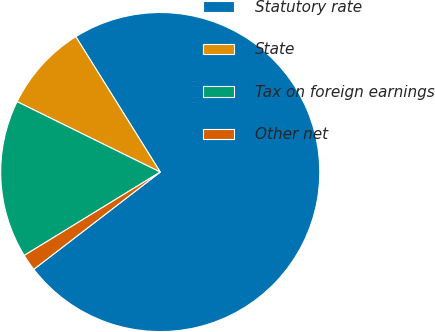Convert chart to OTSL. <chart><loc_0><loc_0><loc_500><loc_500><pie_chart><fcel>Statutory rate<fcel>State<fcel>Tax on foreign earnings<fcel>Other net<nl><fcel>73.44%<fcel>8.85%<fcel>16.03%<fcel>1.68%<nl></chart> 